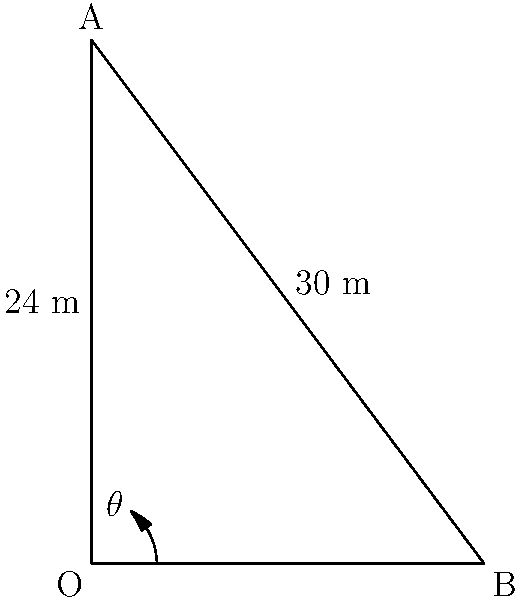During an early morning observation, you notice a group of mountain goats grazing on a steep slope. To estimate the angle of inclination, you measure the vertical height of the slope to be 24 meters and the horizontal distance from the base to the top to be 18 meters. What is the angle of inclination ($\theta$) of the slope? To find the angle of inclination, we can use the trigonometric relationship in a right triangle:

1) In this case, we have a right triangle where:
   - The opposite side (vertical height) is 24 meters
   - The adjacent side (horizontal distance) is 18 meters

2) We can use the tangent function to find the angle:

   $\tan(\theta) = \frac{\text{opposite}}{\text{adjacent}} = \frac{24}{18}$

3) Simplify the fraction:
   $\tan(\theta) = \frac{4}{3}$

4) To find $\theta$, we need to use the inverse tangent (arctan or $\tan^{-1}$):

   $\theta = \tan^{-1}(\frac{4}{3})$

5) Using a calculator or trigonometric tables:

   $\theta \approx 53.13^\circ$

Therefore, the angle of inclination of the slope is approximately 53.13 degrees.
Answer: $53.13^\circ$ 